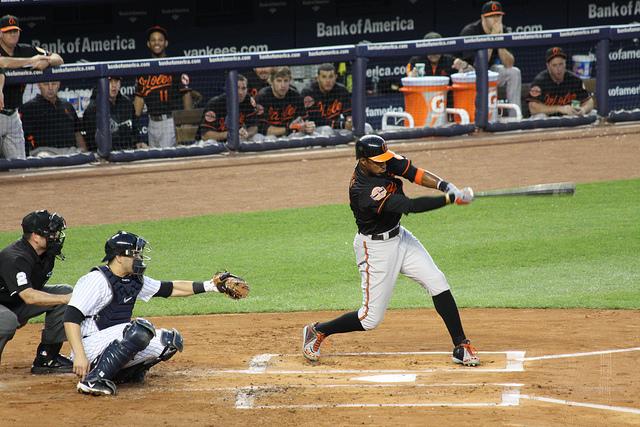How many people are in the photo?
Quick response, please. 13. Has the batter hit the ball yet?
Be succinct. Yes. Are the other players attentive?
Answer briefly. Yes. Would you eat a hot dog at this venue?
Write a very short answer. Yes. What color is the batter's helmet?
Quick response, please. Black and orange. Has the man hit the ball?
Be succinct. Yes. 